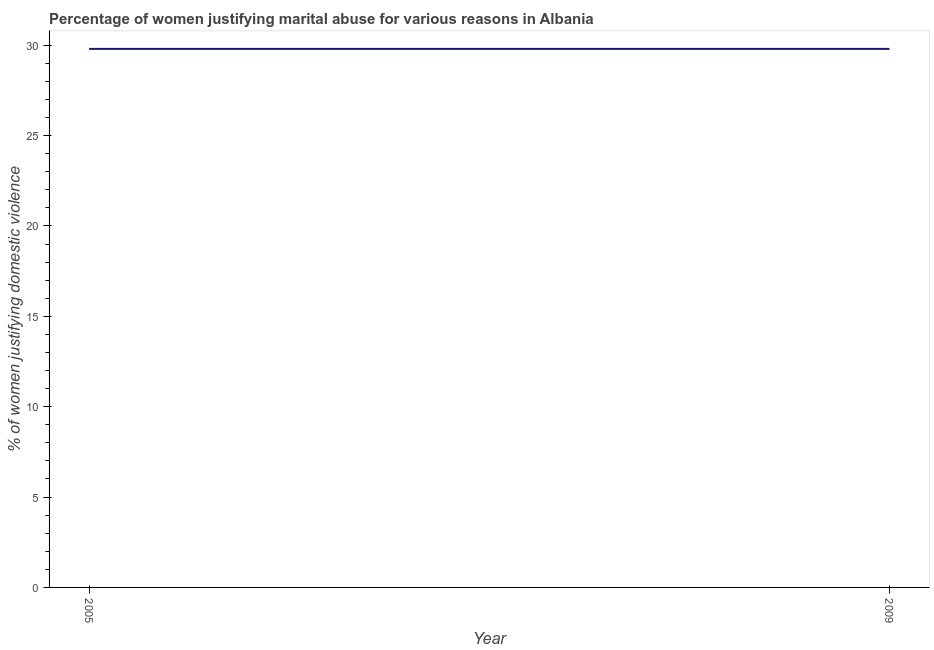What is the percentage of women justifying marital abuse in 2009?
Your response must be concise. 29.8. Across all years, what is the maximum percentage of women justifying marital abuse?
Provide a short and direct response. 29.8. Across all years, what is the minimum percentage of women justifying marital abuse?
Provide a short and direct response. 29.8. What is the sum of the percentage of women justifying marital abuse?
Provide a short and direct response. 59.6. What is the average percentage of women justifying marital abuse per year?
Your response must be concise. 29.8. What is the median percentage of women justifying marital abuse?
Your response must be concise. 29.8. In how many years, is the percentage of women justifying marital abuse greater than 9 %?
Keep it short and to the point. 2. Is the percentage of women justifying marital abuse in 2005 less than that in 2009?
Ensure brevity in your answer.  No. In how many years, is the percentage of women justifying marital abuse greater than the average percentage of women justifying marital abuse taken over all years?
Your answer should be very brief. 0. How many lines are there?
Your answer should be very brief. 1. What is the difference between two consecutive major ticks on the Y-axis?
Provide a succinct answer. 5. Does the graph contain grids?
Provide a succinct answer. No. What is the title of the graph?
Your response must be concise. Percentage of women justifying marital abuse for various reasons in Albania. What is the label or title of the X-axis?
Provide a short and direct response. Year. What is the label or title of the Y-axis?
Offer a very short reply. % of women justifying domestic violence. What is the % of women justifying domestic violence of 2005?
Your answer should be very brief. 29.8. What is the % of women justifying domestic violence of 2009?
Provide a short and direct response. 29.8. What is the ratio of the % of women justifying domestic violence in 2005 to that in 2009?
Give a very brief answer. 1. 